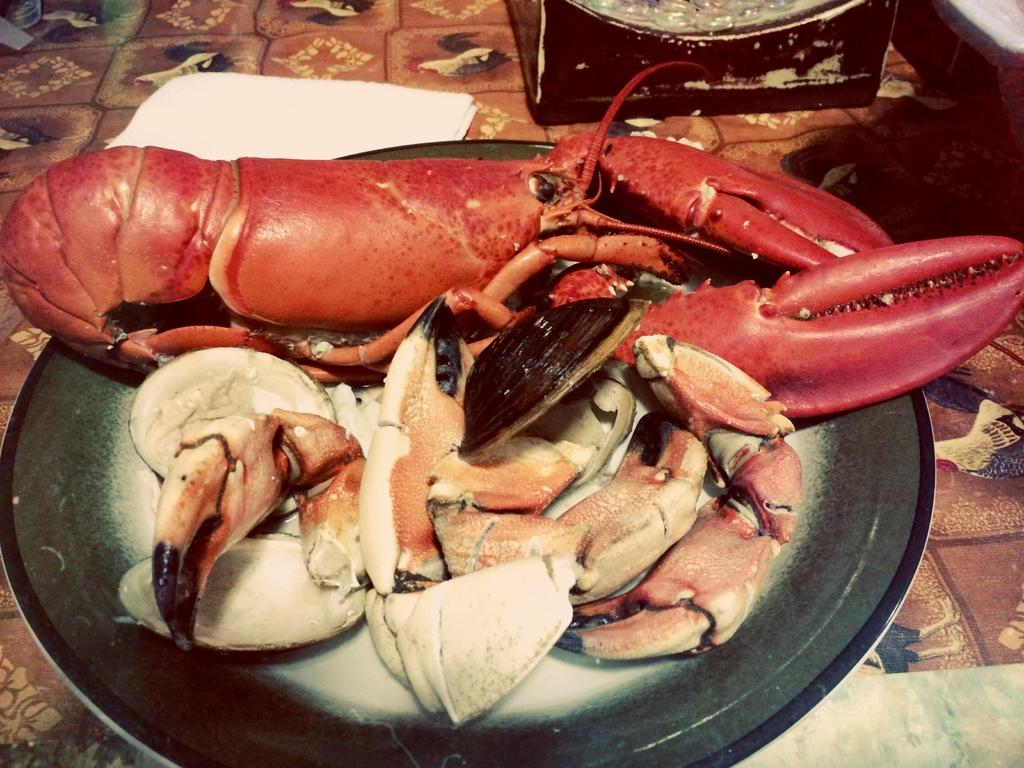What is on the plate that is visible in the image? The plate contains lobster. Are there any other items on the plate besides lobster? Yes, there are shells and other items on the plate. What can be seen at the top of the image? There are additional items at the top of the image. How many times do the people in the image kiss each other? There are no people visible in the image, so it is impossible to determine how many times they might kiss each other. 